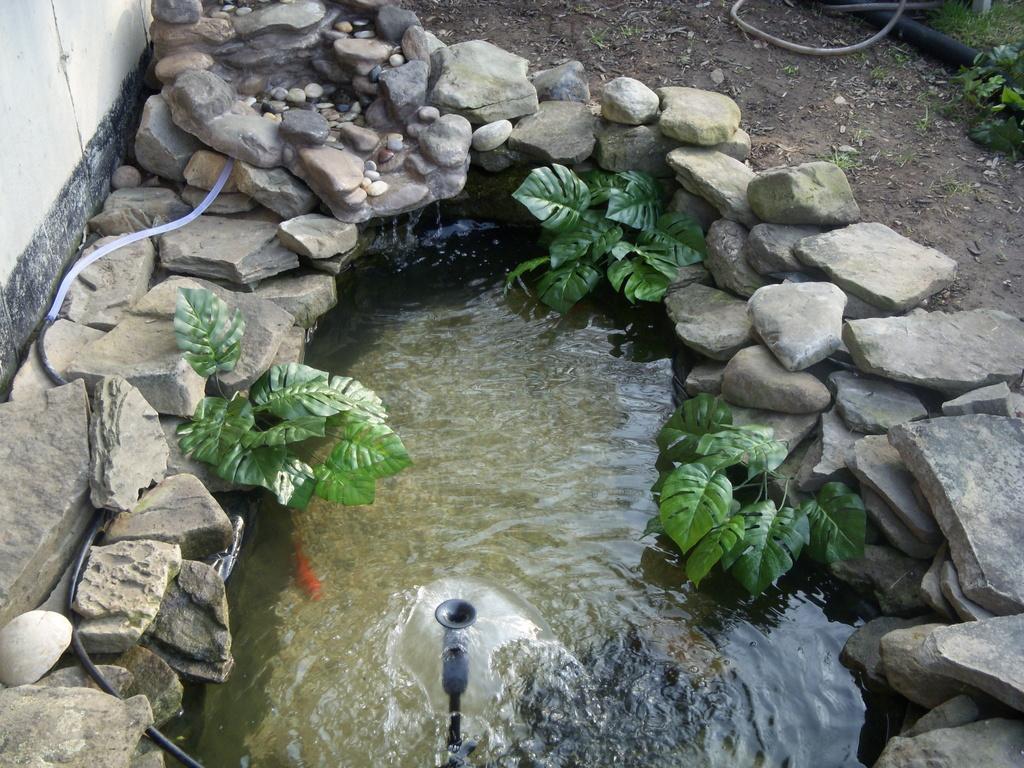Could you give a brief overview of what you see in this image? At the bottom of the image, we can see the water fountain. In this image, we can see, plants, stones and pipes. At the top of the image, we can see wall, ground, plant, grass and pipes. 